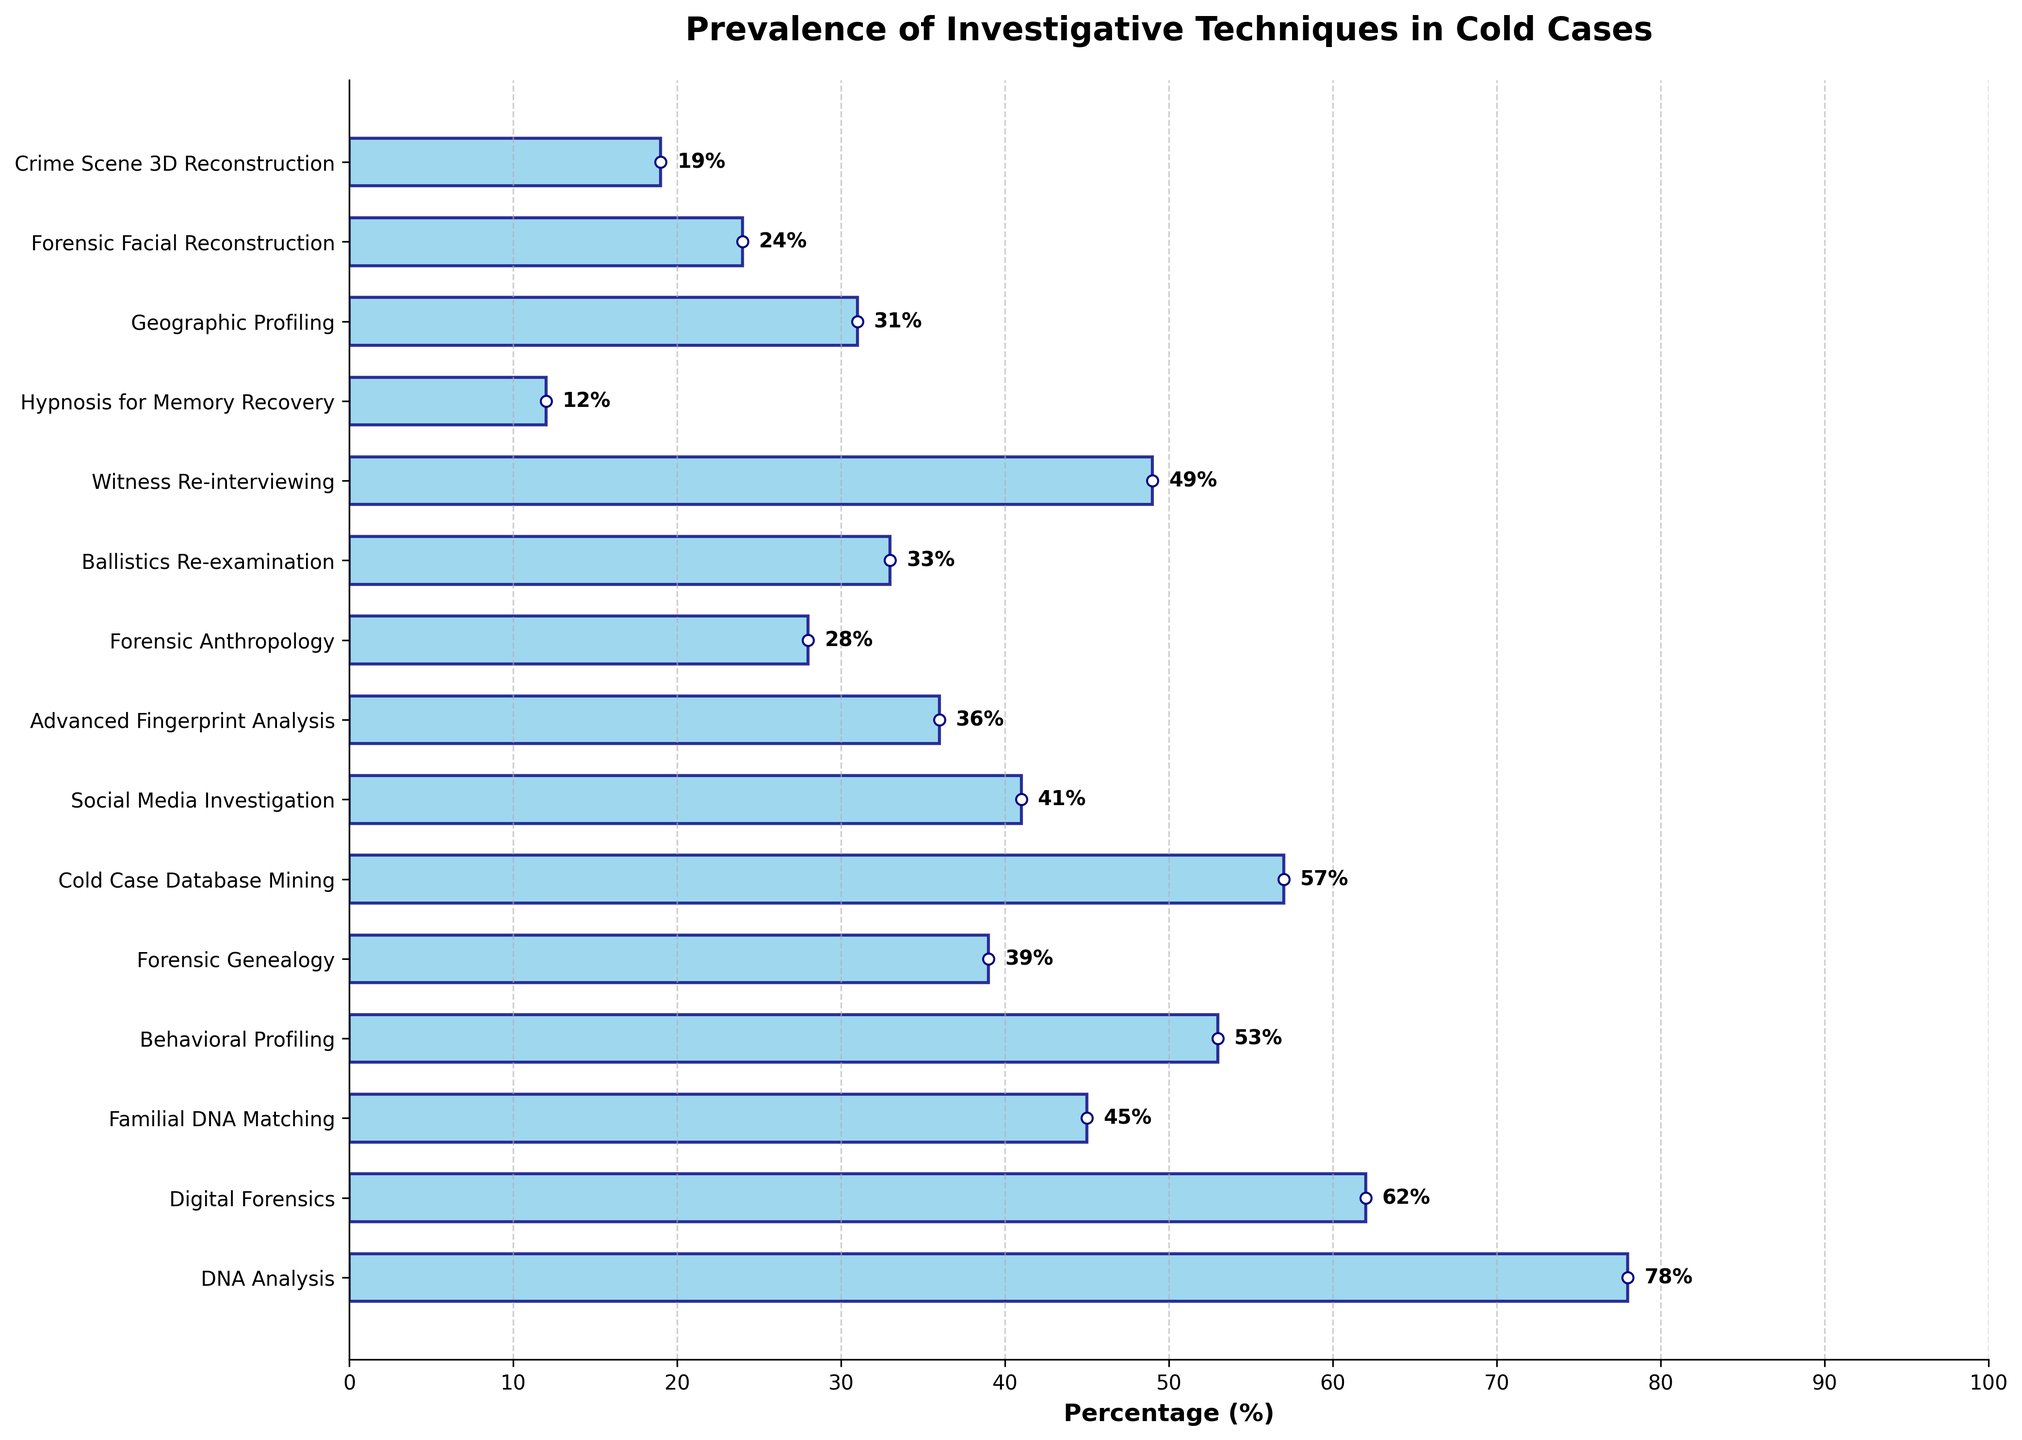What technique is the most prevalent in reopening cold cases? The bar with the highest percentage represents the most prevalent technique. DNA Analysis has a percentage of 78%, which is the highest in the chart.
Answer: DNA Analysis Which technique has a lower prevalence, Forensic Facial Reconstruction or Hypnosis for Memory Recovery? By comparing the lengths of the bars for both techniques, Forensic Facial Reconstruction has a percentage of 24%, while Hypnosis for Memory Recovery has a percentage of 12%.
Answer: Hypnosis for Memory Recovery What is the combined percentage of Digital Forensics and Behavioral Profiling? Sum the percentages of Digital Forensics (62%) and Behavioral Profiling (53%): 62 + 53 = 115
Answer: 115 Which technique has more than double the prevalence of Ballistics Re-examination? First, determine double the percentage of Ballistics Re-examination (33%): 33 * 2 = 66. DNA Analysis (78%) meets this criterion as it is greater than 66.
Answer: DNA Analysis What is the average prevalence of Geographic Profiling, Forensic Genealogy, and Crime Scene 3D Reconstruction? Add the percentages of the three techniques (31% + 39% + 19%) and divide by the number of techniques (3): (31 + 39 + 19) / 3 = 29.67
Answer: 29.67 Are there more techniques with a prevalence over 50% or under 30%? Techniques over 50%: DNA Analysis, Digital Forensics, Behavioral Profiling, Cold Case Database Mining (4). Techniques under 30%: Forensic Anthropology, Ballistics Re-examination, Hypnosis for Memory Recovery, Geographic Profiling, Forensic Facial Reconstruction, Crime Scene 3D Reconstruction (6).
Answer: Under 30% Which technique has the shortest bar in the chart? The bar with the shortest length represents the lowest percentage. Hypnosis for Memory Recovery has the shortest bar with a percentage of 12%.
Answer: Hypnosis for Memory Recovery Which has a higher percentage, Witness Re-interviewing or Social Media Investigation? By comparing the bar lengths, Witness Re-interviewing has a percentage of 49%, while Social Media Investigation has 41%.
Answer: Witness Re-interviewing What is the difference in prevalence between Familial DNA Matching and Advanced Fingerprint Analysis? Subtract the percentage of Advanced Fingerprint Analysis (36%) from that of Familial DNA Matching (45%): 45 - 36 = 9
Answer: 9 If you sum the percentages of the top three most prevalent techniques, what is the total? Identify the top three techniques by percentage: DNA Analysis (78%), Digital Forensics (62%), Behavioral Profiling (53%). Sum these percentages: 78 + 62 + 53 = 193
Answer: 193 